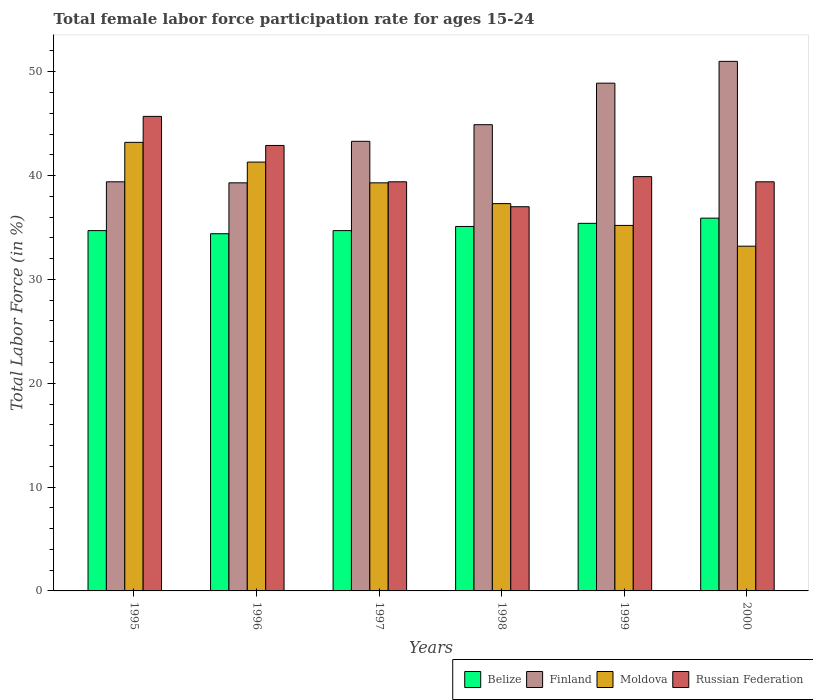How many different coloured bars are there?
Your answer should be compact. 4. How many groups of bars are there?
Ensure brevity in your answer.  6. How many bars are there on the 4th tick from the right?
Make the answer very short. 4. In how many cases, is the number of bars for a given year not equal to the number of legend labels?
Keep it short and to the point. 0. What is the female labor force participation rate in Moldova in 1997?
Provide a short and direct response. 39.3. Across all years, what is the maximum female labor force participation rate in Moldova?
Give a very brief answer. 43.2. In which year was the female labor force participation rate in Moldova maximum?
Ensure brevity in your answer.  1995. In which year was the female labor force participation rate in Belize minimum?
Provide a succinct answer. 1996. What is the total female labor force participation rate in Belize in the graph?
Offer a very short reply. 210.2. What is the difference between the female labor force participation rate in Finland in 1995 and that in 1996?
Offer a very short reply. 0.1. What is the average female labor force participation rate in Finland per year?
Offer a terse response. 44.47. What is the ratio of the female labor force participation rate in Moldova in 1995 to that in 2000?
Provide a short and direct response. 1.3. What is the difference between the highest and the second highest female labor force participation rate in Finland?
Ensure brevity in your answer.  2.1. What is the difference between the highest and the lowest female labor force participation rate in Moldova?
Ensure brevity in your answer.  10. Is the sum of the female labor force participation rate in Moldova in 1996 and 2000 greater than the maximum female labor force participation rate in Belize across all years?
Offer a terse response. Yes. What does the 4th bar from the left in 1998 represents?
Your answer should be compact. Russian Federation. What does the 2nd bar from the right in 1996 represents?
Provide a short and direct response. Moldova. How many years are there in the graph?
Keep it short and to the point. 6. What is the difference between two consecutive major ticks on the Y-axis?
Your answer should be compact. 10. Are the values on the major ticks of Y-axis written in scientific E-notation?
Your answer should be very brief. No. Does the graph contain grids?
Ensure brevity in your answer.  No. Where does the legend appear in the graph?
Provide a short and direct response. Bottom right. How many legend labels are there?
Offer a very short reply. 4. How are the legend labels stacked?
Provide a succinct answer. Horizontal. What is the title of the graph?
Make the answer very short. Total female labor force participation rate for ages 15-24. Does "Slovenia" appear as one of the legend labels in the graph?
Offer a terse response. No. What is the label or title of the Y-axis?
Your answer should be compact. Total Labor Force (in %). What is the Total Labor Force (in %) of Belize in 1995?
Provide a short and direct response. 34.7. What is the Total Labor Force (in %) of Finland in 1995?
Provide a succinct answer. 39.4. What is the Total Labor Force (in %) in Moldova in 1995?
Your answer should be very brief. 43.2. What is the Total Labor Force (in %) of Russian Federation in 1995?
Keep it short and to the point. 45.7. What is the Total Labor Force (in %) of Belize in 1996?
Your answer should be very brief. 34.4. What is the Total Labor Force (in %) in Finland in 1996?
Make the answer very short. 39.3. What is the Total Labor Force (in %) in Moldova in 1996?
Offer a terse response. 41.3. What is the Total Labor Force (in %) of Russian Federation in 1996?
Make the answer very short. 42.9. What is the Total Labor Force (in %) of Belize in 1997?
Your answer should be very brief. 34.7. What is the Total Labor Force (in %) in Finland in 1997?
Offer a terse response. 43.3. What is the Total Labor Force (in %) in Moldova in 1997?
Your answer should be compact. 39.3. What is the Total Labor Force (in %) of Russian Federation in 1997?
Provide a short and direct response. 39.4. What is the Total Labor Force (in %) in Belize in 1998?
Make the answer very short. 35.1. What is the Total Labor Force (in %) of Finland in 1998?
Keep it short and to the point. 44.9. What is the Total Labor Force (in %) in Moldova in 1998?
Offer a very short reply. 37.3. What is the Total Labor Force (in %) in Russian Federation in 1998?
Provide a succinct answer. 37. What is the Total Labor Force (in %) in Belize in 1999?
Give a very brief answer. 35.4. What is the Total Labor Force (in %) in Finland in 1999?
Give a very brief answer. 48.9. What is the Total Labor Force (in %) of Moldova in 1999?
Give a very brief answer. 35.2. What is the Total Labor Force (in %) of Russian Federation in 1999?
Your answer should be very brief. 39.9. What is the Total Labor Force (in %) in Belize in 2000?
Provide a succinct answer. 35.9. What is the Total Labor Force (in %) of Finland in 2000?
Offer a very short reply. 51. What is the Total Labor Force (in %) in Moldova in 2000?
Offer a very short reply. 33.2. What is the Total Labor Force (in %) of Russian Federation in 2000?
Provide a short and direct response. 39.4. Across all years, what is the maximum Total Labor Force (in %) of Belize?
Ensure brevity in your answer.  35.9. Across all years, what is the maximum Total Labor Force (in %) in Moldova?
Your response must be concise. 43.2. Across all years, what is the maximum Total Labor Force (in %) of Russian Federation?
Ensure brevity in your answer.  45.7. Across all years, what is the minimum Total Labor Force (in %) of Belize?
Provide a short and direct response. 34.4. Across all years, what is the minimum Total Labor Force (in %) in Finland?
Ensure brevity in your answer.  39.3. Across all years, what is the minimum Total Labor Force (in %) in Moldova?
Your answer should be compact. 33.2. Across all years, what is the minimum Total Labor Force (in %) in Russian Federation?
Offer a terse response. 37. What is the total Total Labor Force (in %) in Belize in the graph?
Keep it short and to the point. 210.2. What is the total Total Labor Force (in %) of Finland in the graph?
Give a very brief answer. 266.8. What is the total Total Labor Force (in %) in Moldova in the graph?
Your answer should be very brief. 229.5. What is the total Total Labor Force (in %) of Russian Federation in the graph?
Offer a very short reply. 244.3. What is the difference between the Total Labor Force (in %) of Belize in 1995 and that in 1996?
Keep it short and to the point. 0.3. What is the difference between the Total Labor Force (in %) in Finland in 1995 and that in 1996?
Provide a short and direct response. 0.1. What is the difference between the Total Labor Force (in %) of Russian Federation in 1995 and that in 1996?
Give a very brief answer. 2.8. What is the difference between the Total Labor Force (in %) in Moldova in 1995 and that in 1997?
Offer a terse response. 3.9. What is the difference between the Total Labor Force (in %) of Finland in 1995 and that in 1998?
Offer a very short reply. -5.5. What is the difference between the Total Labor Force (in %) in Belize in 1995 and that in 1999?
Offer a terse response. -0.7. What is the difference between the Total Labor Force (in %) in Finland in 1995 and that in 1999?
Provide a short and direct response. -9.5. What is the difference between the Total Labor Force (in %) in Moldova in 1995 and that in 2000?
Provide a succinct answer. 10. What is the difference between the Total Labor Force (in %) in Belize in 1996 and that in 1997?
Ensure brevity in your answer.  -0.3. What is the difference between the Total Labor Force (in %) in Finland in 1996 and that in 1997?
Your answer should be compact. -4. What is the difference between the Total Labor Force (in %) of Belize in 1996 and that in 1998?
Offer a terse response. -0.7. What is the difference between the Total Labor Force (in %) in Moldova in 1996 and that in 1998?
Offer a very short reply. 4. What is the difference between the Total Labor Force (in %) in Russian Federation in 1996 and that in 1998?
Your answer should be compact. 5.9. What is the difference between the Total Labor Force (in %) in Finland in 1996 and that in 1999?
Your answer should be compact. -9.6. What is the difference between the Total Labor Force (in %) in Russian Federation in 1996 and that in 1999?
Make the answer very short. 3. What is the difference between the Total Labor Force (in %) of Belize in 1996 and that in 2000?
Provide a short and direct response. -1.5. What is the difference between the Total Labor Force (in %) in Russian Federation in 1996 and that in 2000?
Offer a terse response. 3.5. What is the difference between the Total Labor Force (in %) in Moldova in 1997 and that in 1998?
Give a very brief answer. 2. What is the difference between the Total Labor Force (in %) of Russian Federation in 1997 and that in 1998?
Keep it short and to the point. 2.4. What is the difference between the Total Labor Force (in %) of Belize in 1997 and that in 1999?
Keep it short and to the point. -0.7. What is the difference between the Total Labor Force (in %) of Moldova in 1997 and that in 2000?
Give a very brief answer. 6.1. What is the difference between the Total Labor Force (in %) of Russian Federation in 1997 and that in 2000?
Keep it short and to the point. 0. What is the difference between the Total Labor Force (in %) of Russian Federation in 1998 and that in 1999?
Offer a very short reply. -2.9. What is the difference between the Total Labor Force (in %) in Russian Federation in 1998 and that in 2000?
Offer a terse response. -2.4. What is the difference between the Total Labor Force (in %) in Belize in 1999 and that in 2000?
Your answer should be compact. -0.5. What is the difference between the Total Labor Force (in %) of Belize in 1995 and the Total Labor Force (in %) of Moldova in 1996?
Your answer should be compact. -6.6. What is the difference between the Total Labor Force (in %) of Finland in 1995 and the Total Labor Force (in %) of Moldova in 1996?
Give a very brief answer. -1.9. What is the difference between the Total Labor Force (in %) in Finland in 1995 and the Total Labor Force (in %) in Russian Federation in 1996?
Provide a short and direct response. -3.5. What is the difference between the Total Labor Force (in %) in Belize in 1995 and the Total Labor Force (in %) in Finland in 1997?
Offer a terse response. -8.6. What is the difference between the Total Labor Force (in %) in Belize in 1995 and the Total Labor Force (in %) in Moldova in 1997?
Give a very brief answer. -4.6. What is the difference between the Total Labor Force (in %) in Belize in 1995 and the Total Labor Force (in %) in Russian Federation in 1997?
Offer a terse response. -4.7. What is the difference between the Total Labor Force (in %) of Finland in 1995 and the Total Labor Force (in %) of Moldova in 1997?
Provide a short and direct response. 0.1. What is the difference between the Total Labor Force (in %) in Belize in 1995 and the Total Labor Force (in %) in Russian Federation in 1998?
Provide a succinct answer. -2.3. What is the difference between the Total Labor Force (in %) of Moldova in 1995 and the Total Labor Force (in %) of Russian Federation in 1998?
Your answer should be compact. 6.2. What is the difference between the Total Labor Force (in %) in Belize in 1995 and the Total Labor Force (in %) in Moldova in 1999?
Offer a very short reply. -0.5. What is the difference between the Total Labor Force (in %) of Belize in 1995 and the Total Labor Force (in %) of Finland in 2000?
Offer a very short reply. -16.3. What is the difference between the Total Labor Force (in %) in Finland in 1995 and the Total Labor Force (in %) in Moldova in 2000?
Your answer should be very brief. 6.2. What is the difference between the Total Labor Force (in %) of Moldova in 1995 and the Total Labor Force (in %) of Russian Federation in 2000?
Give a very brief answer. 3.8. What is the difference between the Total Labor Force (in %) of Belize in 1996 and the Total Labor Force (in %) of Moldova in 1997?
Give a very brief answer. -4.9. What is the difference between the Total Labor Force (in %) in Belize in 1996 and the Total Labor Force (in %) in Russian Federation in 1997?
Ensure brevity in your answer.  -5. What is the difference between the Total Labor Force (in %) in Moldova in 1996 and the Total Labor Force (in %) in Russian Federation in 1997?
Provide a short and direct response. 1.9. What is the difference between the Total Labor Force (in %) of Finland in 1996 and the Total Labor Force (in %) of Russian Federation in 1998?
Make the answer very short. 2.3. What is the difference between the Total Labor Force (in %) in Belize in 1996 and the Total Labor Force (in %) in Moldova in 1999?
Ensure brevity in your answer.  -0.8. What is the difference between the Total Labor Force (in %) in Belize in 1996 and the Total Labor Force (in %) in Russian Federation in 1999?
Provide a short and direct response. -5.5. What is the difference between the Total Labor Force (in %) in Finland in 1996 and the Total Labor Force (in %) in Moldova in 1999?
Ensure brevity in your answer.  4.1. What is the difference between the Total Labor Force (in %) of Finland in 1996 and the Total Labor Force (in %) of Russian Federation in 1999?
Your answer should be very brief. -0.6. What is the difference between the Total Labor Force (in %) of Moldova in 1996 and the Total Labor Force (in %) of Russian Federation in 1999?
Provide a succinct answer. 1.4. What is the difference between the Total Labor Force (in %) of Belize in 1996 and the Total Labor Force (in %) of Finland in 2000?
Give a very brief answer. -16.6. What is the difference between the Total Labor Force (in %) in Belize in 1996 and the Total Labor Force (in %) in Moldova in 2000?
Provide a short and direct response. 1.2. What is the difference between the Total Labor Force (in %) in Finland in 1996 and the Total Labor Force (in %) in Russian Federation in 2000?
Keep it short and to the point. -0.1. What is the difference between the Total Labor Force (in %) in Moldova in 1996 and the Total Labor Force (in %) in Russian Federation in 2000?
Offer a terse response. 1.9. What is the difference between the Total Labor Force (in %) in Finland in 1997 and the Total Labor Force (in %) in Moldova in 1998?
Make the answer very short. 6. What is the difference between the Total Labor Force (in %) in Finland in 1997 and the Total Labor Force (in %) in Russian Federation in 1998?
Ensure brevity in your answer.  6.3. What is the difference between the Total Labor Force (in %) in Moldova in 1997 and the Total Labor Force (in %) in Russian Federation in 1998?
Give a very brief answer. 2.3. What is the difference between the Total Labor Force (in %) of Finland in 1997 and the Total Labor Force (in %) of Moldova in 1999?
Make the answer very short. 8.1. What is the difference between the Total Labor Force (in %) in Moldova in 1997 and the Total Labor Force (in %) in Russian Federation in 1999?
Your response must be concise. -0.6. What is the difference between the Total Labor Force (in %) of Belize in 1997 and the Total Labor Force (in %) of Finland in 2000?
Your answer should be compact. -16.3. What is the difference between the Total Labor Force (in %) in Belize in 1997 and the Total Labor Force (in %) in Russian Federation in 2000?
Provide a short and direct response. -4.7. What is the difference between the Total Labor Force (in %) of Belize in 1998 and the Total Labor Force (in %) of Moldova in 1999?
Provide a short and direct response. -0.1. What is the difference between the Total Labor Force (in %) in Belize in 1998 and the Total Labor Force (in %) in Russian Federation in 1999?
Provide a short and direct response. -4.8. What is the difference between the Total Labor Force (in %) of Finland in 1998 and the Total Labor Force (in %) of Moldova in 1999?
Offer a terse response. 9.7. What is the difference between the Total Labor Force (in %) in Belize in 1998 and the Total Labor Force (in %) in Finland in 2000?
Offer a very short reply. -15.9. What is the difference between the Total Labor Force (in %) in Belize in 1998 and the Total Labor Force (in %) in Russian Federation in 2000?
Keep it short and to the point. -4.3. What is the difference between the Total Labor Force (in %) of Finland in 1998 and the Total Labor Force (in %) of Moldova in 2000?
Your response must be concise. 11.7. What is the difference between the Total Labor Force (in %) in Moldova in 1998 and the Total Labor Force (in %) in Russian Federation in 2000?
Provide a succinct answer. -2.1. What is the difference between the Total Labor Force (in %) of Belize in 1999 and the Total Labor Force (in %) of Finland in 2000?
Your response must be concise. -15.6. What is the difference between the Total Labor Force (in %) of Belize in 1999 and the Total Labor Force (in %) of Moldova in 2000?
Provide a succinct answer. 2.2. What is the difference between the Total Labor Force (in %) in Finland in 1999 and the Total Labor Force (in %) in Moldova in 2000?
Provide a short and direct response. 15.7. What is the difference between the Total Labor Force (in %) in Moldova in 1999 and the Total Labor Force (in %) in Russian Federation in 2000?
Ensure brevity in your answer.  -4.2. What is the average Total Labor Force (in %) in Belize per year?
Offer a very short reply. 35.03. What is the average Total Labor Force (in %) in Finland per year?
Provide a short and direct response. 44.47. What is the average Total Labor Force (in %) of Moldova per year?
Offer a very short reply. 38.25. What is the average Total Labor Force (in %) in Russian Federation per year?
Keep it short and to the point. 40.72. In the year 1995, what is the difference between the Total Labor Force (in %) in Belize and Total Labor Force (in %) in Finland?
Your response must be concise. -4.7. In the year 1995, what is the difference between the Total Labor Force (in %) of Belize and Total Labor Force (in %) of Russian Federation?
Provide a succinct answer. -11. In the year 1996, what is the difference between the Total Labor Force (in %) of Belize and Total Labor Force (in %) of Finland?
Give a very brief answer. -4.9. In the year 1996, what is the difference between the Total Labor Force (in %) of Belize and Total Labor Force (in %) of Moldova?
Provide a short and direct response. -6.9. In the year 1996, what is the difference between the Total Labor Force (in %) in Belize and Total Labor Force (in %) in Russian Federation?
Your response must be concise. -8.5. In the year 1996, what is the difference between the Total Labor Force (in %) in Finland and Total Labor Force (in %) in Moldova?
Your answer should be very brief. -2. In the year 1996, what is the difference between the Total Labor Force (in %) of Moldova and Total Labor Force (in %) of Russian Federation?
Give a very brief answer. -1.6. In the year 1997, what is the difference between the Total Labor Force (in %) in Belize and Total Labor Force (in %) in Finland?
Give a very brief answer. -8.6. In the year 1997, what is the difference between the Total Labor Force (in %) in Finland and Total Labor Force (in %) in Moldova?
Your response must be concise. 4. In the year 1997, what is the difference between the Total Labor Force (in %) in Moldova and Total Labor Force (in %) in Russian Federation?
Ensure brevity in your answer.  -0.1. In the year 1998, what is the difference between the Total Labor Force (in %) of Belize and Total Labor Force (in %) of Finland?
Ensure brevity in your answer.  -9.8. In the year 1998, what is the difference between the Total Labor Force (in %) in Belize and Total Labor Force (in %) in Moldova?
Give a very brief answer. -2.2. In the year 1998, what is the difference between the Total Labor Force (in %) in Belize and Total Labor Force (in %) in Russian Federation?
Offer a terse response. -1.9. In the year 1998, what is the difference between the Total Labor Force (in %) in Finland and Total Labor Force (in %) in Moldova?
Your answer should be very brief. 7.6. In the year 1998, what is the difference between the Total Labor Force (in %) in Finland and Total Labor Force (in %) in Russian Federation?
Offer a very short reply. 7.9. In the year 1998, what is the difference between the Total Labor Force (in %) of Moldova and Total Labor Force (in %) of Russian Federation?
Offer a terse response. 0.3. In the year 1999, what is the difference between the Total Labor Force (in %) in Belize and Total Labor Force (in %) in Finland?
Provide a short and direct response. -13.5. In the year 1999, what is the difference between the Total Labor Force (in %) of Moldova and Total Labor Force (in %) of Russian Federation?
Your answer should be very brief. -4.7. In the year 2000, what is the difference between the Total Labor Force (in %) of Belize and Total Labor Force (in %) of Finland?
Your response must be concise. -15.1. In the year 2000, what is the difference between the Total Labor Force (in %) in Belize and Total Labor Force (in %) in Moldova?
Keep it short and to the point. 2.7. In the year 2000, what is the difference between the Total Labor Force (in %) in Belize and Total Labor Force (in %) in Russian Federation?
Make the answer very short. -3.5. In the year 2000, what is the difference between the Total Labor Force (in %) in Finland and Total Labor Force (in %) in Moldova?
Offer a very short reply. 17.8. In the year 2000, what is the difference between the Total Labor Force (in %) of Finland and Total Labor Force (in %) of Russian Federation?
Your response must be concise. 11.6. What is the ratio of the Total Labor Force (in %) in Belize in 1995 to that in 1996?
Provide a succinct answer. 1.01. What is the ratio of the Total Labor Force (in %) of Finland in 1995 to that in 1996?
Offer a very short reply. 1. What is the ratio of the Total Labor Force (in %) of Moldova in 1995 to that in 1996?
Your answer should be compact. 1.05. What is the ratio of the Total Labor Force (in %) in Russian Federation in 1995 to that in 1996?
Ensure brevity in your answer.  1.07. What is the ratio of the Total Labor Force (in %) in Finland in 1995 to that in 1997?
Your answer should be very brief. 0.91. What is the ratio of the Total Labor Force (in %) in Moldova in 1995 to that in 1997?
Give a very brief answer. 1.1. What is the ratio of the Total Labor Force (in %) of Russian Federation in 1995 to that in 1997?
Make the answer very short. 1.16. What is the ratio of the Total Labor Force (in %) in Finland in 1995 to that in 1998?
Offer a terse response. 0.88. What is the ratio of the Total Labor Force (in %) in Moldova in 1995 to that in 1998?
Ensure brevity in your answer.  1.16. What is the ratio of the Total Labor Force (in %) of Russian Federation in 1995 to that in 1998?
Your response must be concise. 1.24. What is the ratio of the Total Labor Force (in %) of Belize in 1995 to that in 1999?
Offer a very short reply. 0.98. What is the ratio of the Total Labor Force (in %) of Finland in 1995 to that in 1999?
Ensure brevity in your answer.  0.81. What is the ratio of the Total Labor Force (in %) in Moldova in 1995 to that in 1999?
Ensure brevity in your answer.  1.23. What is the ratio of the Total Labor Force (in %) of Russian Federation in 1995 to that in 1999?
Keep it short and to the point. 1.15. What is the ratio of the Total Labor Force (in %) of Belize in 1995 to that in 2000?
Your response must be concise. 0.97. What is the ratio of the Total Labor Force (in %) of Finland in 1995 to that in 2000?
Offer a terse response. 0.77. What is the ratio of the Total Labor Force (in %) in Moldova in 1995 to that in 2000?
Your answer should be compact. 1.3. What is the ratio of the Total Labor Force (in %) of Russian Federation in 1995 to that in 2000?
Your answer should be very brief. 1.16. What is the ratio of the Total Labor Force (in %) in Finland in 1996 to that in 1997?
Give a very brief answer. 0.91. What is the ratio of the Total Labor Force (in %) in Moldova in 1996 to that in 1997?
Keep it short and to the point. 1.05. What is the ratio of the Total Labor Force (in %) in Russian Federation in 1996 to that in 1997?
Keep it short and to the point. 1.09. What is the ratio of the Total Labor Force (in %) of Belize in 1996 to that in 1998?
Keep it short and to the point. 0.98. What is the ratio of the Total Labor Force (in %) of Finland in 1996 to that in 1998?
Your answer should be very brief. 0.88. What is the ratio of the Total Labor Force (in %) of Moldova in 1996 to that in 1998?
Your response must be concise. 1.11. What is the ratio of the Total Labor Force (in %) in Russian Federation in 1996 to that in 1998?
Your answer should be compact. 1.16. What is the ratio of the Total Labor Force (in %) of Belize in 1996 to that in 1999?
Offer a terse response. 0.97. What is the ratio of the Total Labor Force (in %) in Finland in 1996 to that in 1999?
Provide a succinct answer. 0.8. What is the ratio of the Total Labor Force (in %) in Moldova in 1996 to that in 1999?
Provide a succinct answer. 1.17. What is the ratio of the Total Labor Force (in %) of Russian Federation in 1996 to that in 1999?
Provide a short and direct response. 1.08. What is the ratio of the Total Labor Force (in %) in Belize in 1996 to that in 2000?
Make the answer very short. 0.96. What is the ratio of the Total Labor Force (in %) in Finland in 1996 to that in 2000?
Keep it short and to the point. 0.77. What is the ratio of the Total Labor Force (in %) of Moldova in 1996 to that in 2000?
Your response must be concise. 1.24. What is the ratio of the Total Labor Force (in %) of Russian Federation in 1996 to that in 2000?
Your answer should be very brief. 1.09. What is the ratio of the Total Labor Force (in %) of Finland in 1997 to that in 1998?
Your answer should be compact. 0.96. What is the ratio of the Total Labor Force (in %) in Moldova in 1997 to that in 1998?
Your response must be concise. 1.05. What is the ratio of the Total Labor Force (in %) of Russian Federation in 1997 to that in 1998?
Ensure brevity in your answer.  1.06. What is the ratio of the Total Labor Force (in %) of Belize in 1997 to that in 1999?
Provide a short and direct response. 0.98. What is the ratio of the Total Labor Force (in %) of Finland in 1997 to that in 1999?
Make the answer very short. 0.89. What is the ratio of the Total Labor Force (in %) in Moldova in 1997 to that in 1999?
Provide a succinct answer. 1.12. What is the ratio of the Total Labor Force (in %) in Russian Federation in 1997 to that in 1999?
Keep it short and to the point. 0.99. What is the ratio of the Total Labor Force (in %) of Belize in 1997 to that in 2000?
Offer a very short reply. 0.97. What is the ratio of the Total Labor Force (in %) of Finland in 1997 to that in 2000?
Your answer should be compact. 0.85. What is the ratio of the Total Labor Force (in %) of Moldova in 1997 to that in 2000?
Your answer should be very brief. 1.18. What is the ratio of the Total Labor Force (in %) in Finland in 1998 to that in 1999?
Keep it short and to the point. 0.92. What is the ratio of the Total Labor Force (in %) of Moldova in 1998 to that in 1999?
Provide a succinct answer. 1.06. What is the ratio of the Total Labor Force (in %) in Russian Federation in 1998 to that in 1999?
Make the answer very short. 0.93. What is the ratio of the Total Labor Force (in %) in Belize in 1998 to that in 2000?
Offer a terse response. 0.98. What is the ratio of the Total Labor Force (in %) of Finland in 1998 to that in 2000?
Make the answer very short. 0.88. What is the ratio of the Total Labor Force (in %) of Moldova in 1998 to that in 2000?
Ensure brevity in your answer.  1.12. What is the ratio of the Total Labor Force (in %) of Russian Federation in 1998 to that in 2000?
Keep it short and to the point. 0.94. What is the ratio of the Total Labor Force (in %) in Belize in 1999 to that in 2000?
Offer a terse response. 0.99. What is the ratio of the Total Labor Force (in %) in Finland in 1999 to that in 2000?
Ensure brevity in your answer.  0.96. What is the ratio of the Total Labor Force (in %) in Moldova in 1999 to that in 2000?
Keep it short and to the point. 1.06. What is the ratio of the Total Labor Force (in %) in Russian Federation in 1999 to that in 2000?
Offer a very short reply. 1.01. What is the difference between the highest and the second highest Total Labor Force (in %) of Moldova?
Ensure brevity in your answer.  1.9. What is the difference between the highest and the second highest Total Labor Force (in %) of Russian Federation?
Keep it short and to the point. 2.8. What is the difference between the highest and the lowest Total Labor Force (in %) of Moldova?
Your answer should be compact. 10. What is the difference between the highest and the lowest Total Labor Force (in %) of Russian Federation?
Provide a short and direct response. 8.7. 